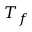Convert formula to latex. <formula><loc_0><loc_0><loc_500><loc_500>T _ { f }</formula> 